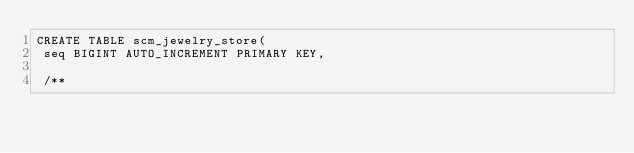Convert code to text. <code><loc_0><loc_0><loc_500><loc_500><_SQL_>CREATE TABLE scm_jewelry_store(
 seq BIGINT AUTO_INCREMENT PRIMARY KEY,

 /**</code> 